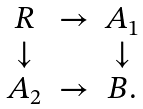Convert formula to latex. <formula><loc_0><loc_0><loc_500><loc_500>\begin{array} { c c c } R & \rightarrow & A _ { 1 } \\ \downarrow & & \downarrow \\ A _ { 2 } & \rightarrow & B . \end{array}</formula> 